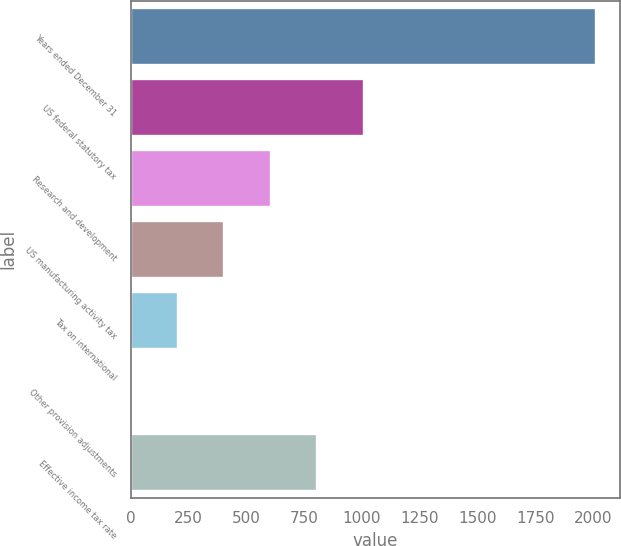Convert chart to OTSL. <chart><loc_0><loc_0><loc_500><loc_500><bar_chart><fcel>Years ended December 31<fcel>US federal statutory tax<fcel>Research and development<fcel>US manufacturing activity tax<fcel>Tax on international<fcel>Other provision adjustments<fcel>Effective income tax rate<nl><fcel>2015<fcel>1007.7<fcel>604.78<fcel>403.32<fcel>201.86<fcel>0.4<fcel>806.24<nl></chart> 